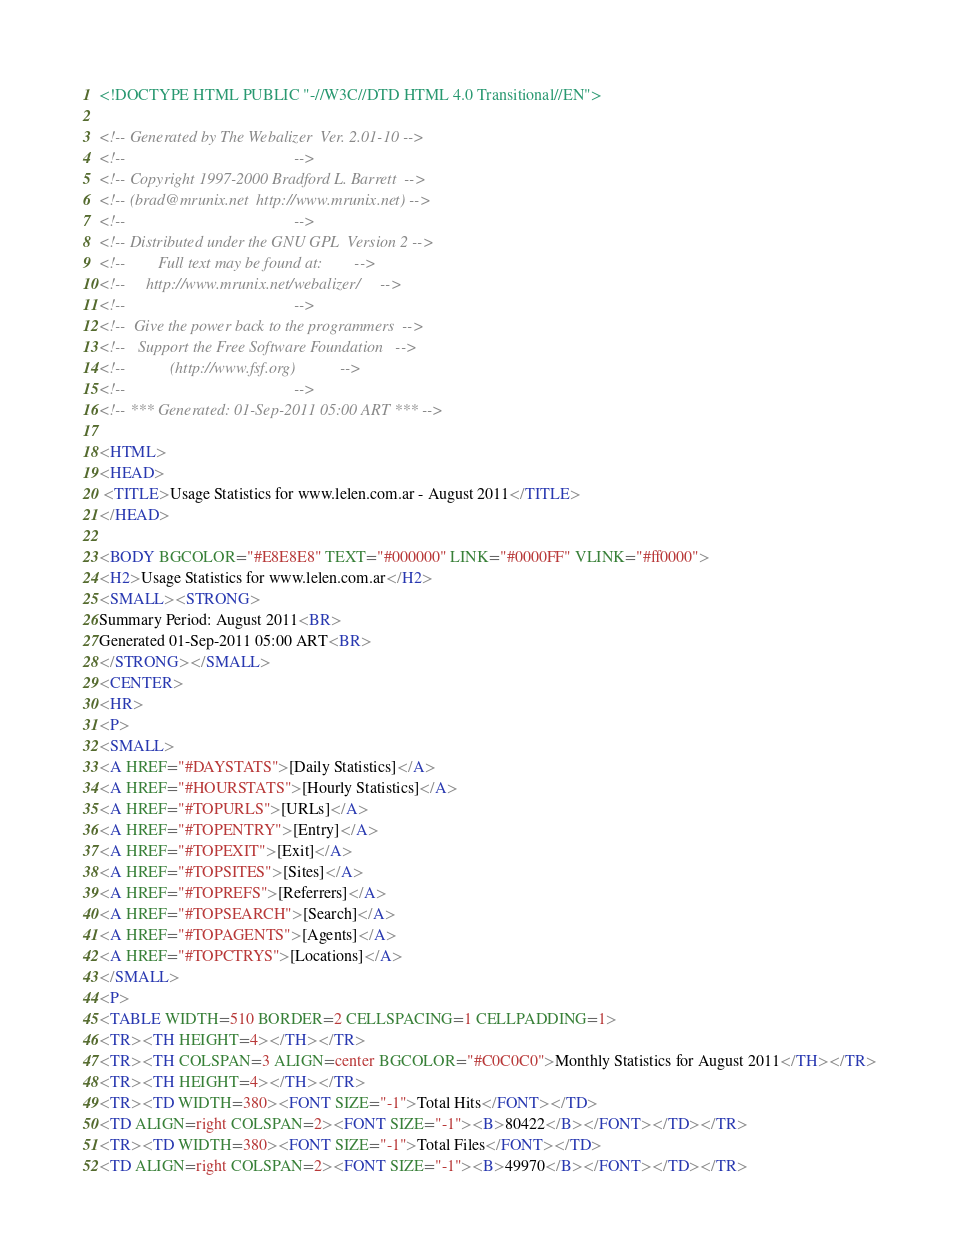<code> <loc_0><loc_0><loc_500><loc_500><_HTML_><!DOCTYPE HTML PUBLIC "-//W3C//DTD HTML 4.0 Transitional//EN">

<!-- Generated by The Webalizer  Ver. 2.01-10 -->
<!--                                          -->
<!-- Copyright 1997-2000 Bradford L. Barrett  -->
<!-- (brad@mrunix.net  http://www.mrunix.net) -->
<!--                                          -->
<!-- Distributed under the GNU GPL  Version 2 -->
<!--        Full text may be found at:        -->
<!--     http://www.mrunix.net/webalizer/     -->
<!--                                          -->
<!--  Give the power back to the programmers  -->
<!--   Support the Free Software Foundation   -->
<!--           (http://www.fsf.org)           -->
<!--                                          -->
<!-- *** Generated: 01-Sep-2011 05:00 ART *** -->

<HTML>
<HEAD>
 <TITLE>Usage Statistics for www.lelen.com.ar - August 2011</TITLE>
</HEAD>

<BODY BGCOLOR="#E8E8E8" TEXT="#000000" LINK="#0000FF" VLINK="#ff0000">
<H2>Usage Statistics for www.lelen.com.ar</H2>
<SMALL><STRONG>
Summary Period: August 2011<BR>
Generated 01-Sep-2011 05:00 ART<BR>
</STRONG></SMALL>
<CENTER>
<HR>
<P>
<SMALL>
<A HREF="#DAYSTATS">[Daily Statistics]</A>
<A HREF="#HOURSTATS">[Hourly Statistics]</A>
<A HREF="#TOPURLS">[URLs]</A>
<A HREF="#TOPENTRY">[Entry]</A>
<A HREF="#TOPEXIT">[Exit]</A>
<A HREF="#TOPSITES">[Sites]</A>
<A HREF="#TOPREFS">[Referrers]</A>
<A HREF="#TOPSEARCH">[Search]</A>
<A HREF="#TOPAGENTS">[Agents]</A>
<A HREF="#TOPCTRYS">[Locations]</A>
</SMALL>
<P>
<TABLE WIDTH=510 BORDER=2 CELLSPACING=1 CELLPADDING=1>
<TR><TH HEIGHT=4></TH></TR>
<TR><TH COLSPAN=3 ALIGN=center BGCOLOR="#C0C0C0">Monthly Statistics for August 2011</TH></TR>
<TR><TH HEIGHT=4></TH></TR>
<TR><TD WIDTH=380><FONT SIZE="-1">Total Hits</FONT></TD>
<TD ALIGN=right COLSPAN=2><FONT SIZE="-1"><B>80422</B></FONT></TD></TR>
<TR><TD WIDTH=380><FONT SIZE="-1">Total Files</FONT></TD>
<TD ALIGN=right COLSPAN=2><FONT SIZE="-1"><B>49970</B></FONT></TD></TR></code> 